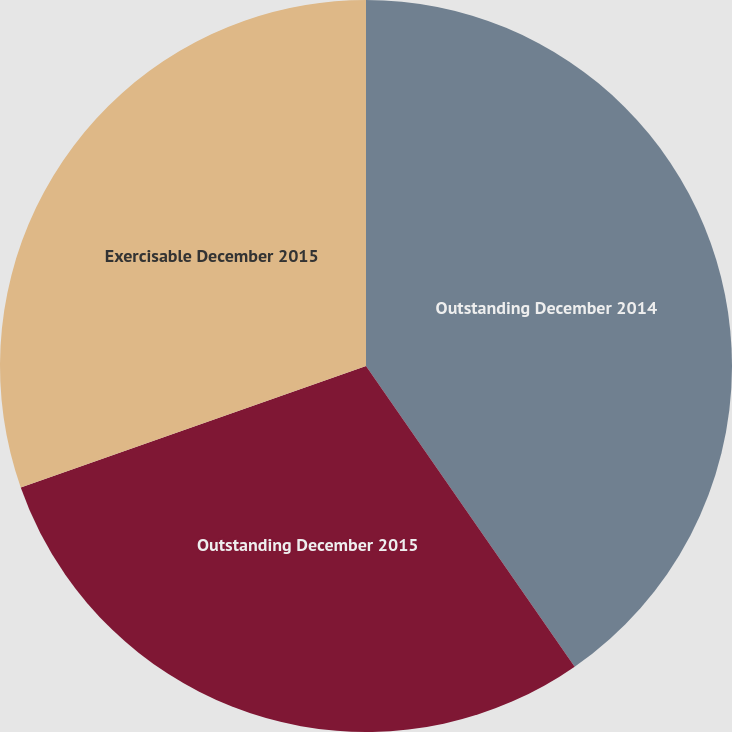Convert chart. <chart><loc_0><loc_0><loc_500><loc_500><pie_chart><fcel>Outstanding December 2014<fcel>Outstanding December 2015<fcel>Exercisable December 2015<nl><fcel>40.34%<fcel>29.27%<fcel>30.38%<nl></chart> 